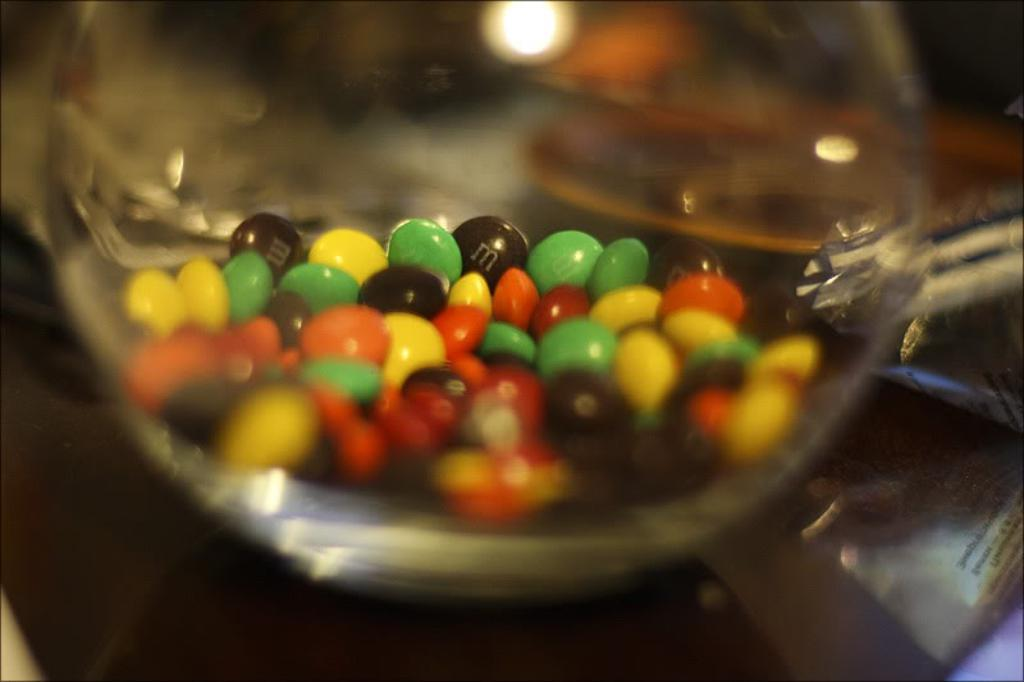What type of food is present in the image? There are chocolates in the image. Can you describe the background of the chocolates? The background of the chocolates is blurred. What type of lead can be seen in the image? There is no lead present in the image; it features chocolates with a blurred background. What type of drug is visible in the image? There is no drug present in the image; it features chocolates with a blurred background. 